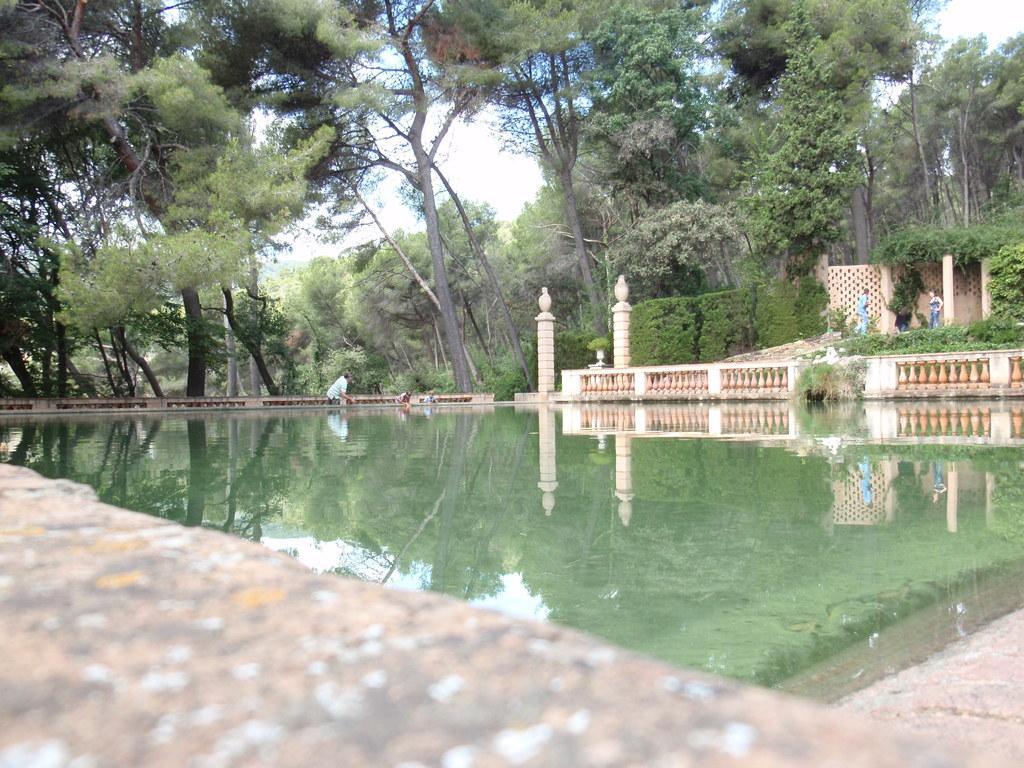Please provide a concise description of this image. In this image at the bottom there is one lake and a wall. And in the background there is a building, railing, poles and some persons and trees. 